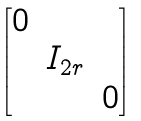<formula> <loc_0><loc_0><loc_500><loc_500>\begin{bmatrix} 0 & & \\ & I _ { 2 r } & \\ & & 0 \end{bmatrix}</formula> 